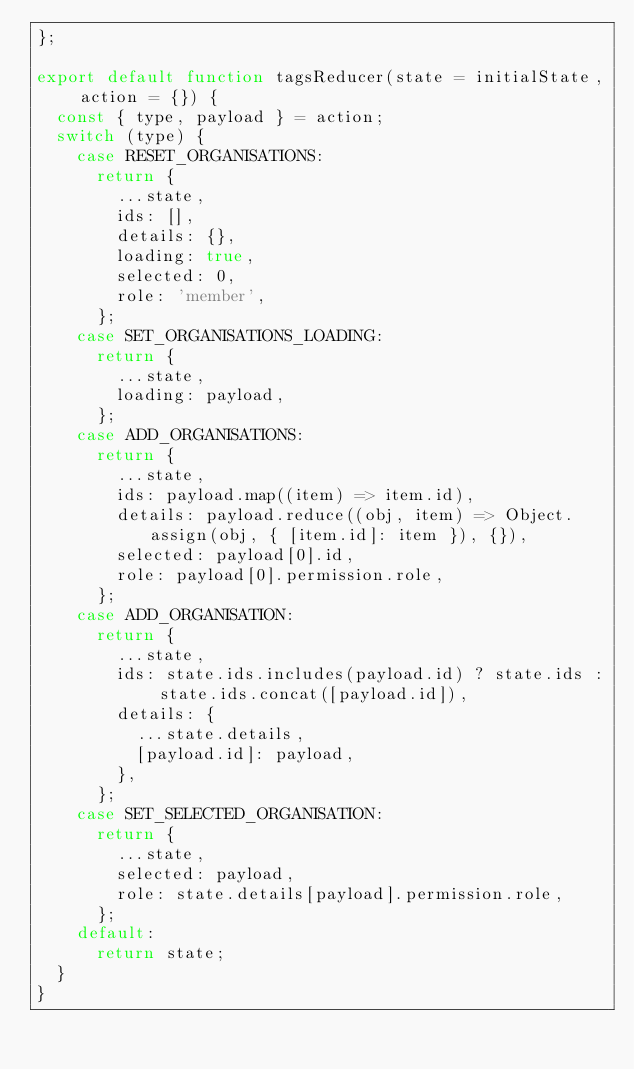<code> <loc_0><loc_0><loc_500><loc_500><_JavaScript_>};

export default function tagsReducer(state = initialState, action = {}) {
  const { type, payload } = action;
  switch (type) {
    case RESET_ORGANISATIONS:
      return {
        ...state,
        ids: [],
        details: {},
        loading: true,
        selected: 0,
        role: 'member',
      };
    case SET_ORGANISATIONS_LOADING:
      return {
        ...state,
        loading: payload,
      };
    case ADD_ORGANISATIONS:
      return {
        ...state,
        ids: payload.map((item) => item.id),
        details: payload.reduce((obj, item) => Object.assign(obj, { [item.id]: item }), {}),
        selected: payload[0].id,
        role: payload[0].permission.role,
      };
    case ADD_ORGANISATION:
      return {
        ...state,
        ids: state.ids.includes(payload.id) ? state.ids : state.ids.concat([payload.id]),
        details: {
          ...state.details,
          [payload.id]: payload,
        },
      };
    case SET_SELECTED_ORGANISATION:
      return {
        ...state,
        selected: payload,
        role: state.details[payload].permission.role,
      };
    default:
      return state;
  }
}
</code> 